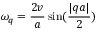Convert formula to latex. <formula><loc_0><loc_0><loc_500><loc_500>\omega _ { q } = \frac { 2 v } { a } \sin ( \frac { | q a | } { 2 } )</formula> 